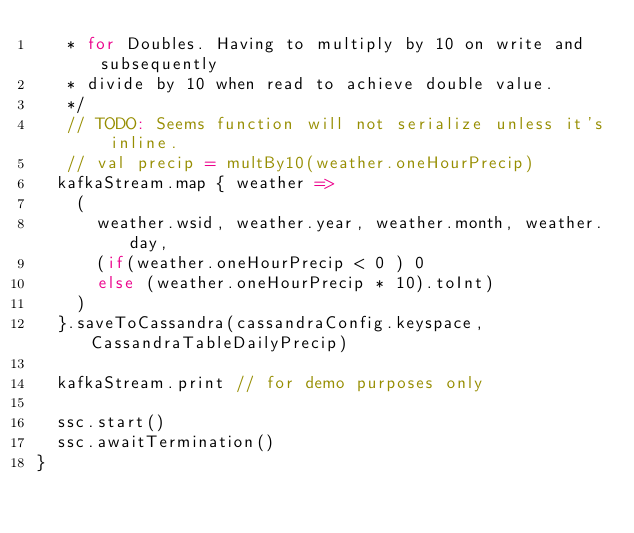<code> <loc_0><loc_0><loc_500><loc_500><_Scala_>   * for Doubles. Having to multiply by 10 on write and subsequently 
   * divide by 10 when read to achieve double value.
   */
   // TODO: Seems function will not serialize unless it's inline.
   // val precip = multBy10(weather.oneHourPrecip)
  kafkaStream.map { weather =>
    (
      weather.wsid, weather.year, weather.month, weather.day, 
      (if(weather.oneHourPrecip < 0 ) 0 
      else (weather.oneHourPrecip * 10).toInt)
    )
  }.saveToCassandra(cassandraConfig.keyspace, CassandraTableDailyPrecip)

  kafkaStream.print // for demo purposes only  

  ssc.start()
  ssc.awaitTermination()
}
</code> 